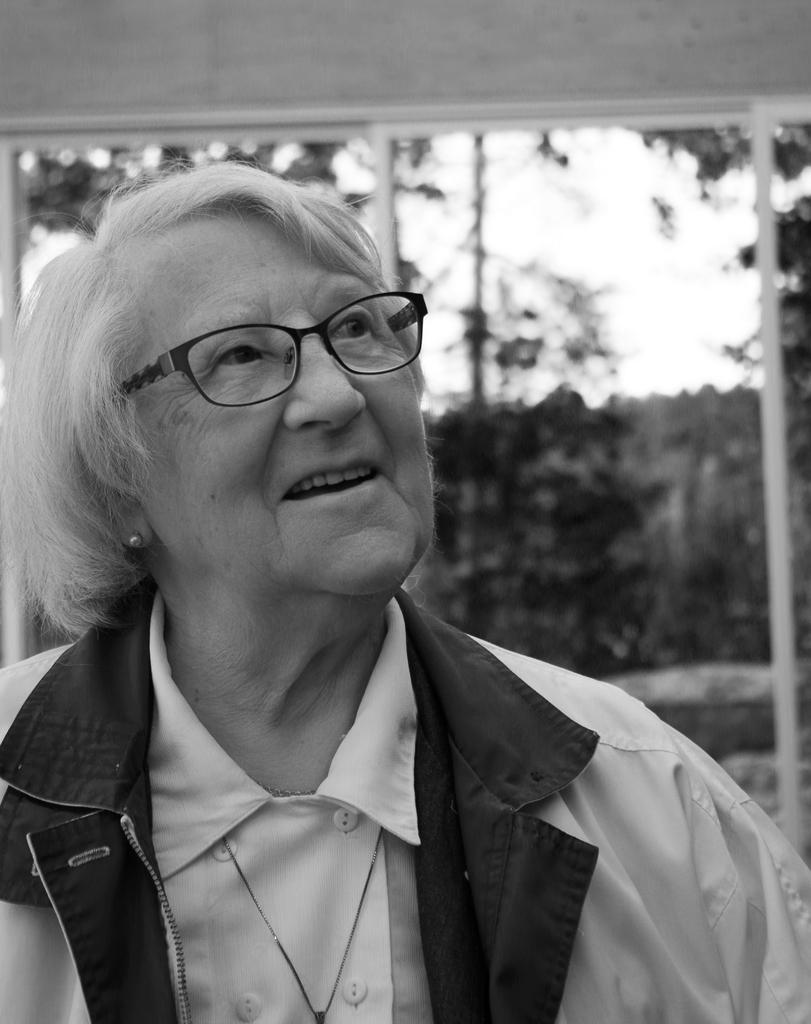Please provide a concise description of this image. There is a woman in white color jacket smiling. In the background, there are white color poles which are attached to the wall, there are trees and clouds in the sky. 